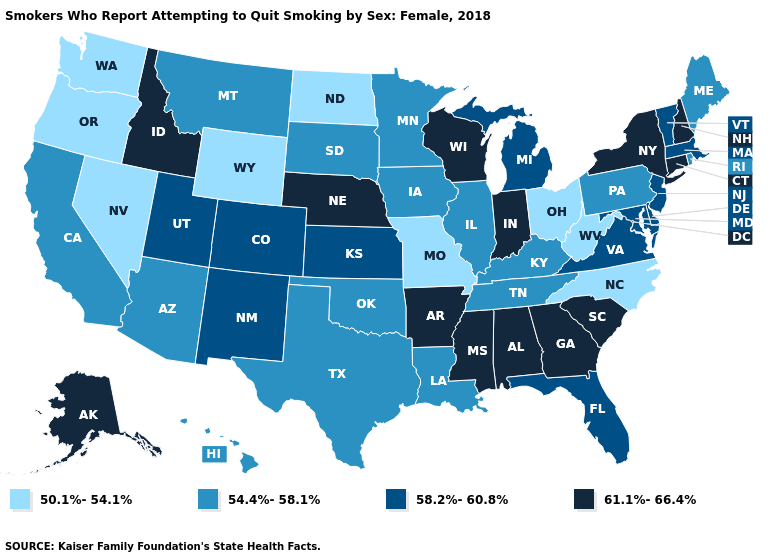Name the states that have a value in the range 61.1%-66.4%?
Short answer required. Alabama, Alaska, Arkansas, Connecticut, Georgia, Idaho, Indiana, Mississippi, Nebraska, New Hampshire, New York, South Carolina, Wisconsin. What is the value of Wisconsin?
Answer briefly. 61.1%-66.4%. Among the states that border Illinois , does Iowa have the highest value?
Short answer required. No. Does Wisconsin have a lower value than New Jersey?
Keep it brief. No. What is the lowest value in the South?
Keep it brief. 50.1%-54.1%. Which states hav the highest value in the MidWest?
Short answer required. Indiana, Nebraska, Wisconsin. What is the value of Delaware?
Short answer required. 58.2%-60.8%. Among the states that border Delaware , which have the highest value?
Answer briefly. Maryland, New Jersey. What is the value of Illinois?
Quick response, please. 54.4%-58.1%. Does the first symbol in the legend represent the smallest category?
Concise answer only. Yes. What is the lowest value in the West?
Short answer required. 50.1%-54.1%. What is the value of Nevada?
Answer briefly. 50.1%-54.1%. Does Arizona have a higher value than Maryland?
Write a very short answer. No. Among the states that border Wisconsin , which have the highest value?
Answer briefly. Michigan. 